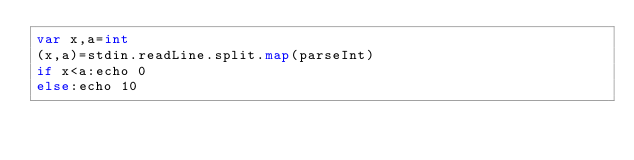<code> <loc_0><loc_0><loc_500><loc_500><_Nim_>var x,a=int
(x,a)=stdin.readLine.split.map(parseInt)
if x<a:echo 0
else:echo 10</code> 